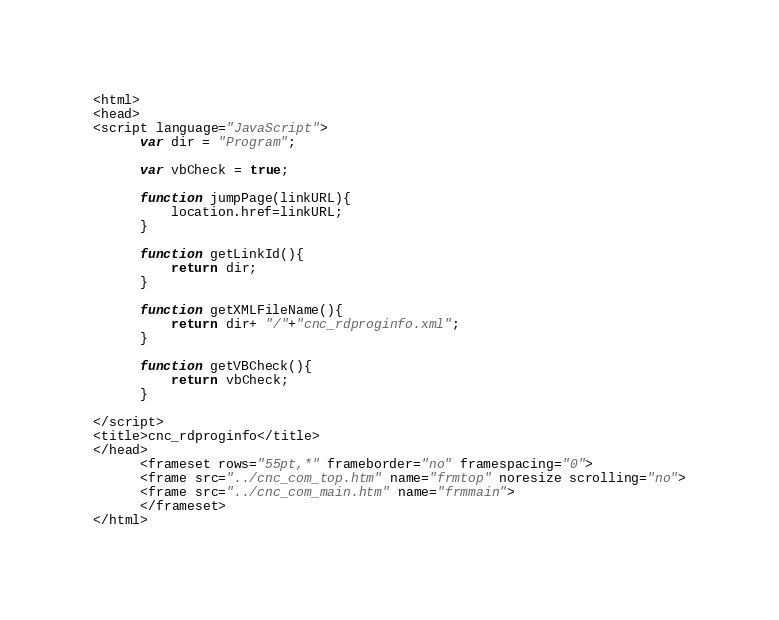<code> <loc_0><loc_0><loc_500><loc_500><_HTML_><html>
<head>
<script language="JavaScript">
      var dir = "Program";

      var vbCheck = true;

      function jumpPage(linkURL){
          location.href=linkURL;
      }

      function getLinkId(){
          return dir;
      }

      function getXMLFileName(){
          return dir+ "/"+"cnc_rdproginfo.xml";
      }

      function getVBCheck(){
          return vbCheck;
      }

</script>
<title>cnc_rdproginfo</title>
</head>
      <frameset rows="55pt,*" frameborder="no" framespacing="0">
      <frame src="../cnc_com_top.htm" name="frmtop" noresize scrolling="no">
      <frame src="../cnc_com_main.htm" name="frmmain">
      </frameset>
</html>
</code> 